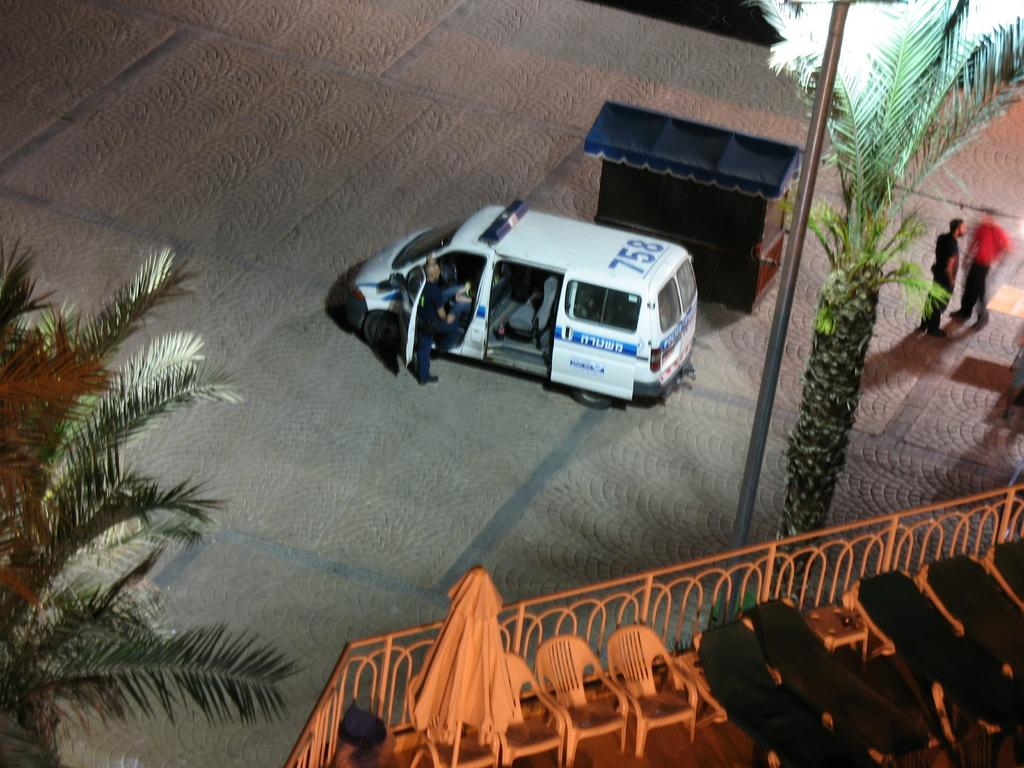What is the main subject of the image? There is a vehicle in the image. Can you describe the people in the image? There are three people on the road in the image. What type of natural elements can be seen in the image? There are trees in the image. What type of establishment is present in the image? There is a small shop in the shop in the image. What architectural feature is present in the image? There is a fence in the image. What type of furniture is near the fence in the image? There are chairs near the fence in the image. What type of object is on a pole in the image? There is a cloth on a pole in the image. What type of soup is being served in the small shop in the image? There is no soup being served in the small shop in the image. The image does not show any food or drink items. 